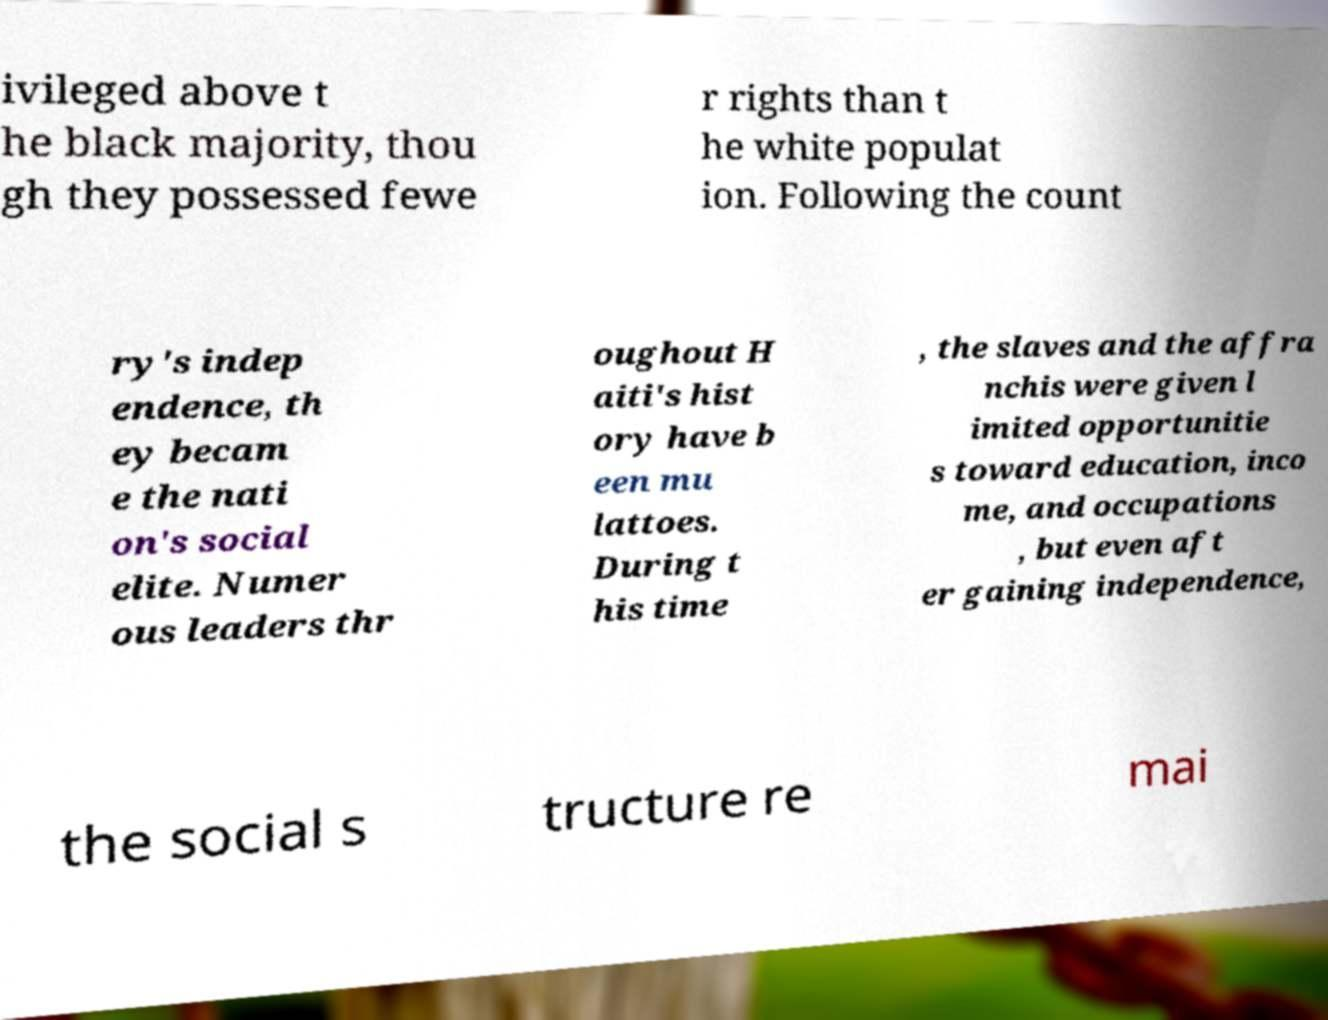Could you extract and type out the text from this image? ivileged above t he black majority, thou gh they possessed fewe r rights than t he white populat ion. Following the count ry's indep endence, th ey becam e the nati on's social elite. Numer ous leaders thr oughout H aiti's hist ory have b een mu lattoes. During t his time , the slaves and the affra nchis were given l imited opportunitie s toward education, inco me, and occupations , but even aft er gaining independence, the social s tructure re mai 